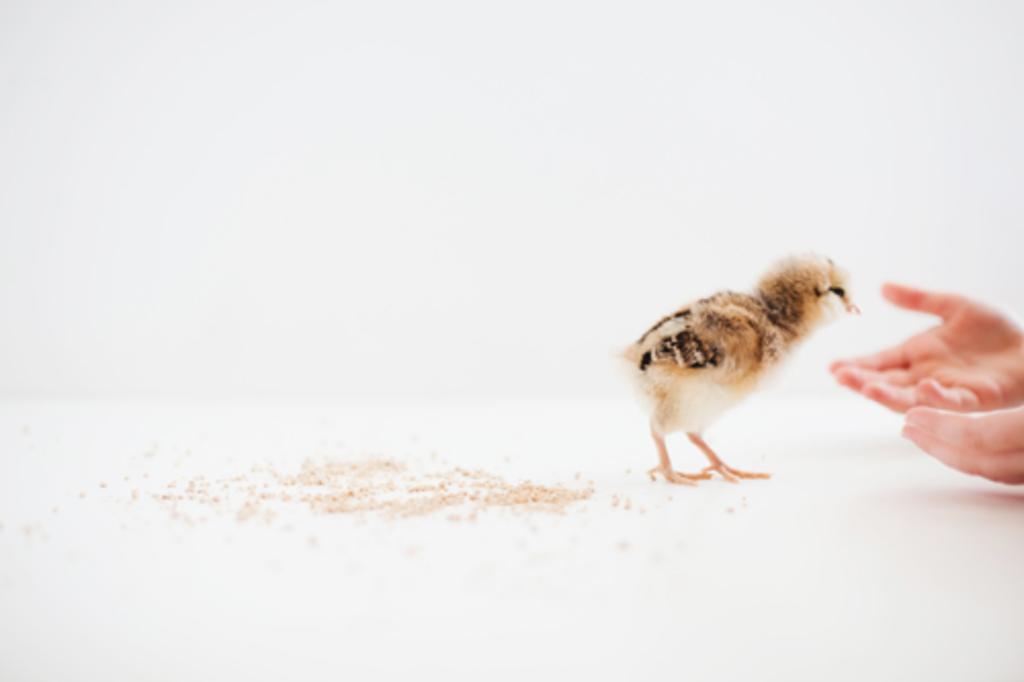Describe this image in one or two sentences. In this image there is a chick in middle of this image and there is a white color floor in the bottom of this image and there is a white color background on the top of this image. 